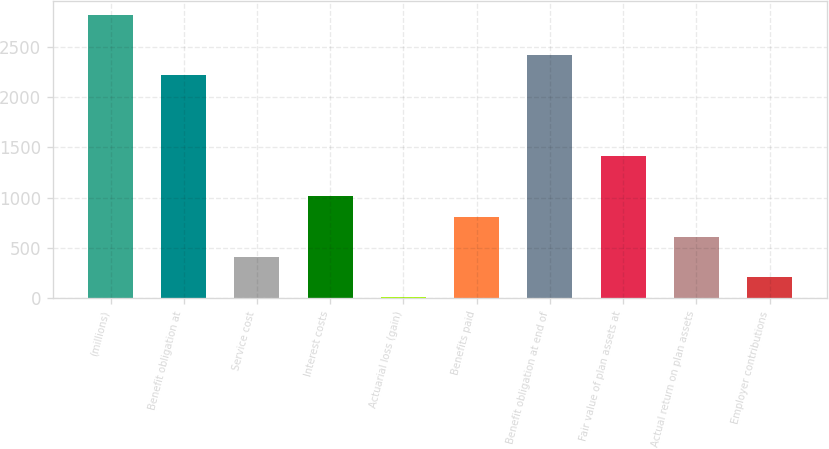Convert chart to OTSL. <chart><loc_0><loc_0><loc_500><loc_500><bar_chart><fcel>(millions)<fcel>Benefit obligation at<fcel>Service cost<fcel>Interest costs<fcel>Actuarial loss (gain)<fcel>Benefits paid<fcel>Benefit obligation at end of<fcel>Fair value of plan assets at<fcel>Actual return on plan assets<fcel>Employer contributions<nl><fcel>2818.16<fcel>2216.54<fcel>411.68<fcel>1013.3<fcel>10.6<fcel>812.76<fcel>2417.08<fcel>1414.38<fcel>612.22<fcel>211.14<nl></chart> 